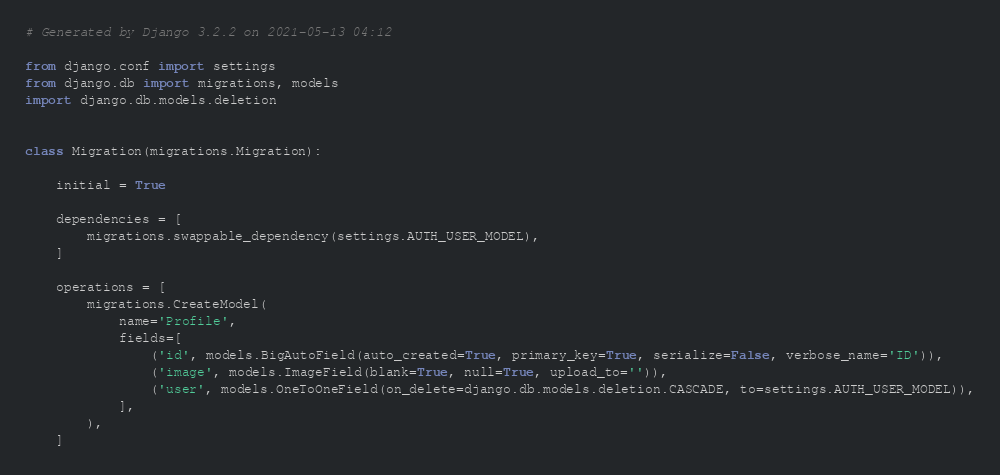<code> <loc_0><loc_0><loc_500><loc_500><_Python_># Generated by Django 3.2.2 on 2021-05-13 04:12

from django.conf import settings
from django.db import migrations, models
import django.db.models.deletion


class Migration(migrations.Migration):

    initial = True

    dependencies = [
        migrations.swappable_dependency(settings.AUTH_USER_MODEL),
    ]

    operations = [
        migrations.CreateModel(
            name='Profile',
            fields=[
                ('id', models.BigAutoField(auto_created=True, primary_key=True, serialize=False, verbose_name='ID')),
                ('image', models.ImageField(blank=True, null=True, upload_to='')),
                ('user', models.OneToOneField(on_delete=django.db.models.deletion.CASCADE, to=settings.AUTH_USER_MODEL)),
            ],
        ),
    ]
</code> 